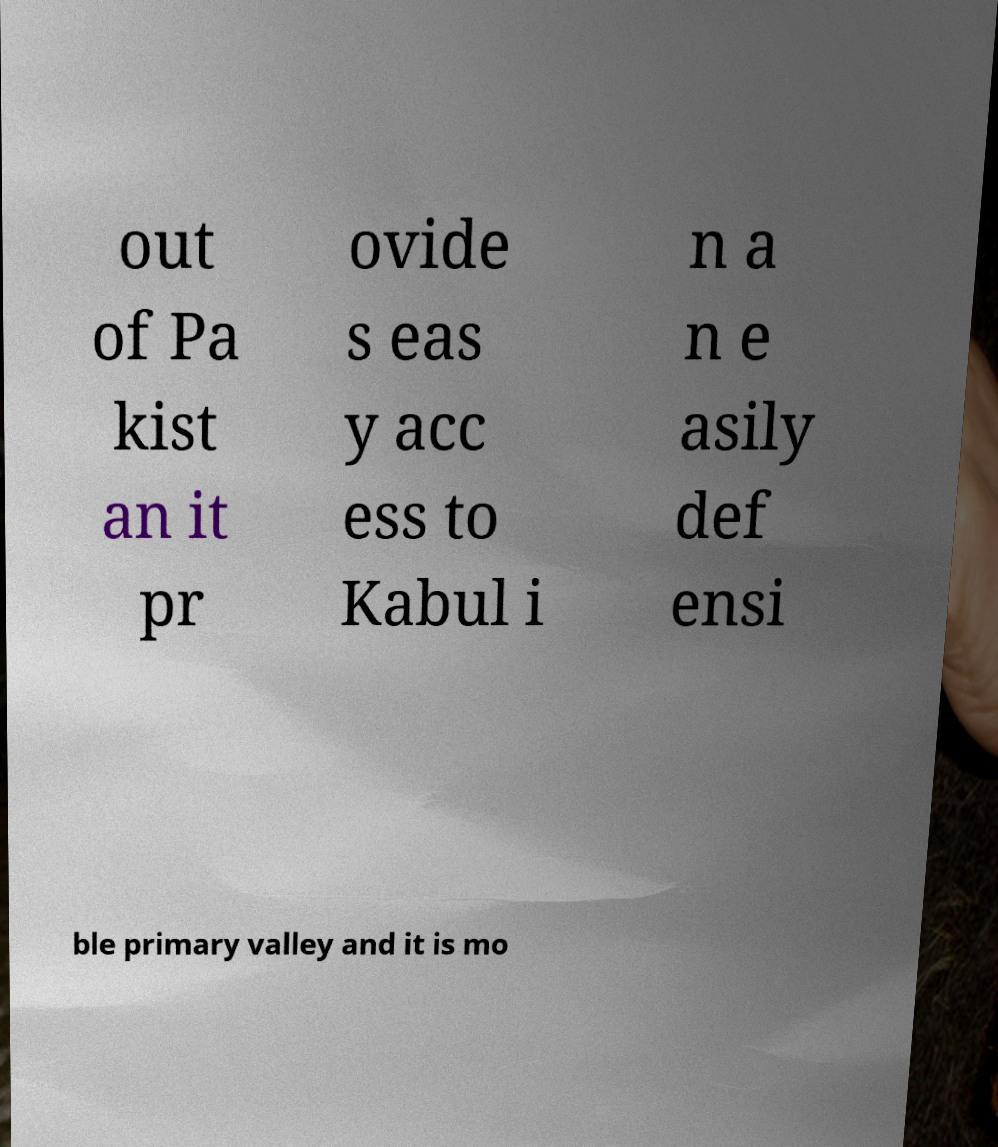I need the written content from this picture converted into text. Can you do that? out of Pa kist an it pr ovide s eas y acc ess to Kabul i n a n e asily def ensi ble primary valley and it is mo 